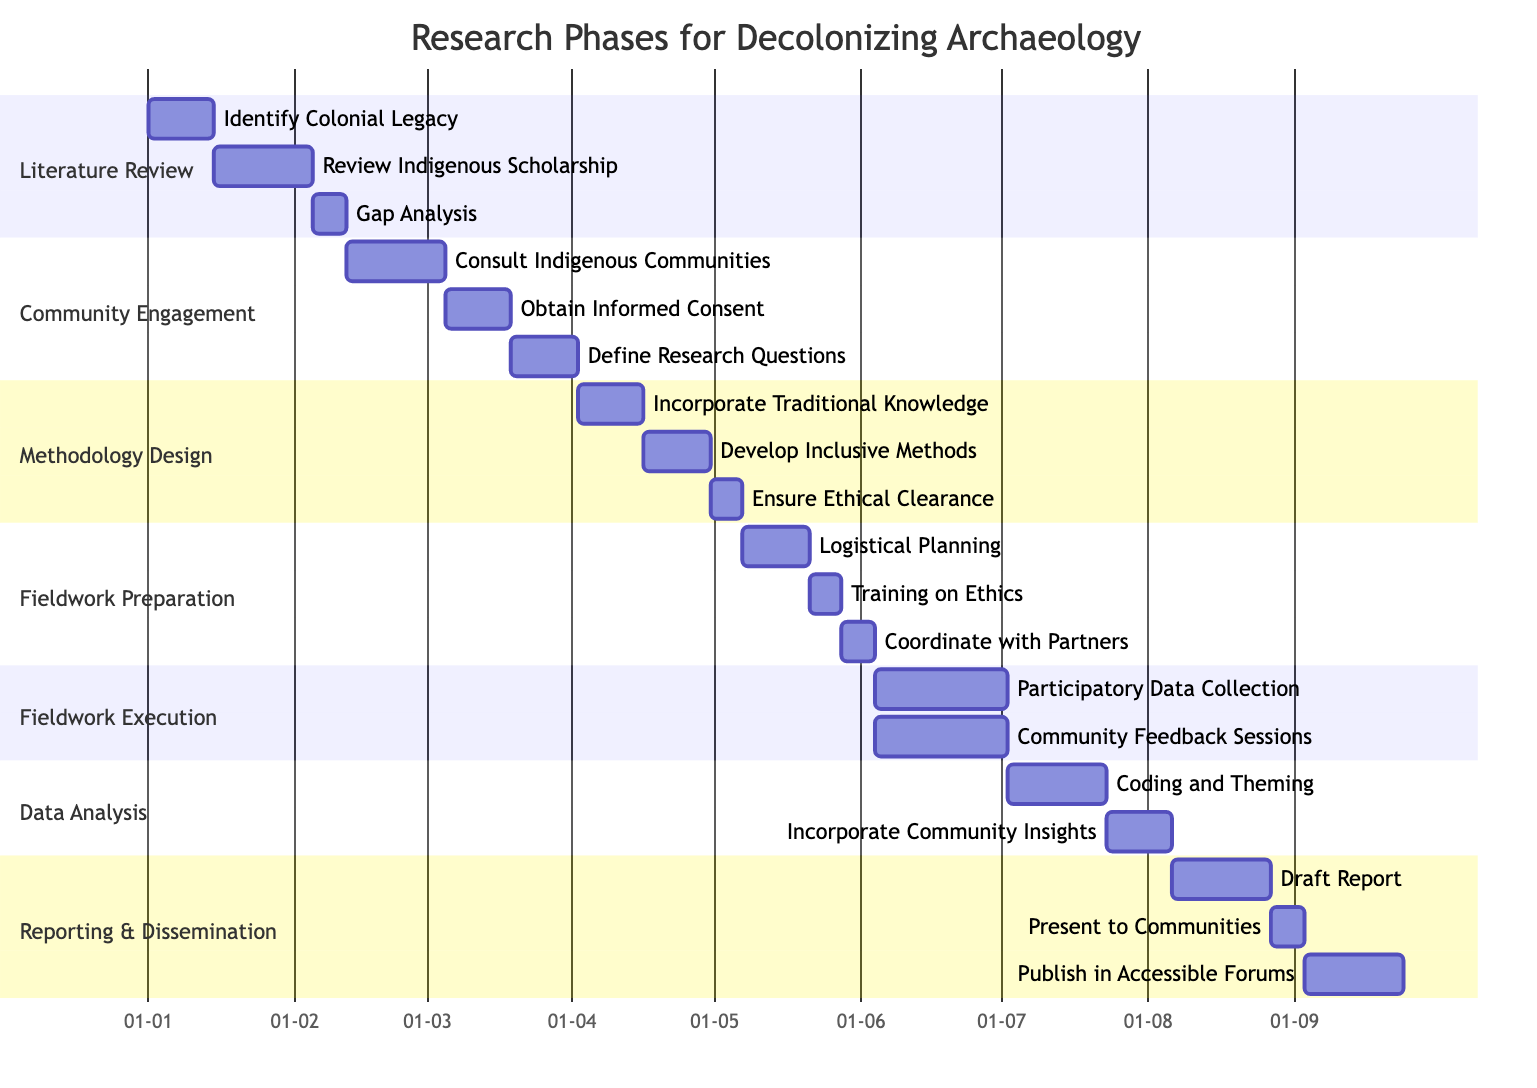What are the total number of phases in the research? The diagram lists seven distinct phases under the "section" header. By counting each phase under that header, we determine the total.
Answer: 7 What is the duration of the "Consult Local Indigenous Communities" task? By locating the task in the "Community Engagement" phase, we see it is stated to last for three weeks.
Answer: 3 weeks In which phase does the task "Incorporate Community Insights" occur? Looking through the phases in the diagram, we find that this task is part of the "Data Analysis" phase listed in the corresponding section.
Answer: Data Analysis How many weeks does the "Fieldwork Execution" take in total? The "Fieldwork Execution" phase includes two tasks: "Participatory Data Collection" (4 weeks) and "Regular Community Feedback Sessions" (4 weeks). Adding these durations gives a total of 8 weeks.
Answer: 8 weeks Which task directly precedes "Present Findings to Local Communities"? From the "Reporting & Dissemination" phase, the task "Draft Report with Community Input" comes immediately before "Present Findings to Local Communities," as seen in the sequence of tasks listed.
Answer: Draft Report with Community Input How many weeks are allocated for training on ethical considerations? The diagram specifies that the task "Training on Ethical Considerations" in the "Fieldwork Preparation" phase has a duration of one week.
Answer: 1 week What is the start date for the "Gap Analysis in Existing Research"? Within the "Literature Review" section, the task "Gap Analysis" is indicated to begin on February 5, 2023, after the previous tasks are completed.
Answer: 2023-02-05 Which phase includes tasks that focus on community engagement? The "Community Engagement" phase explicitly includes tasks aimed at consulting and working collaboratively with local Indigenous communities, making it the focus of engagement in this research.
Answer: Community Engagement How many tasks are included in the "Methodology Design" phase? Examining the "Methodology Design" section reveals three distinct tasks, which can be counted directly off the diagram.
Answer: 3 